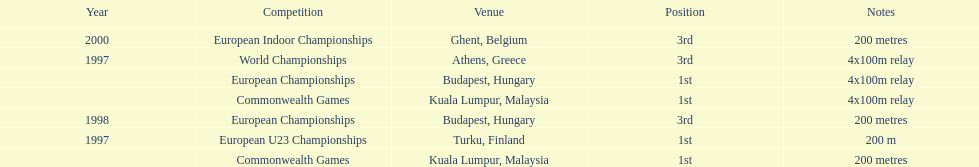How many events were won in malaysia? 2. 